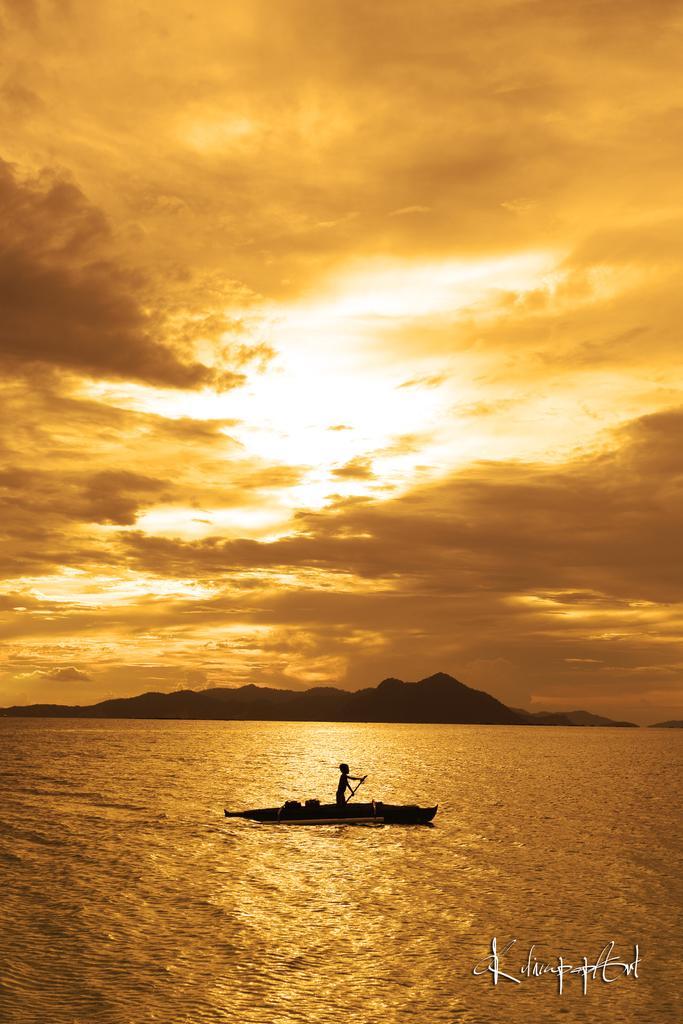In one or two sentences, can you explain what this image depicts? In this image there is one standing on the boat and and holding one paddle and there is a sea at bottom of this image. There are some mountains in the background and there is a cloudy sky at top of this image. There is one watermark is at bottom right corner of this image. 